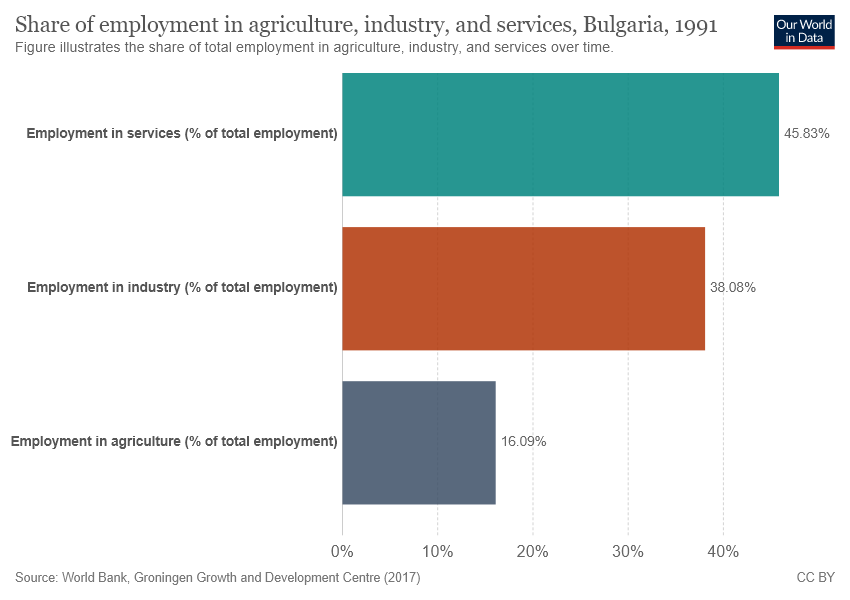Specify some key components in this picture. The difference in employment sector values between the highest and lowest sectors is 29.74. The brown bar represents the value of employment in industry, which is a part of the total employment. 